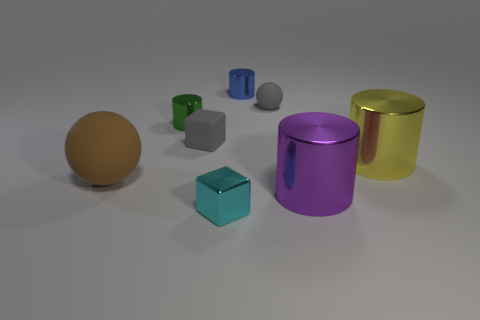Add 2 large yellow cylinders. How many objects exist? 10 Subtract all spheres. How many objects are left? 6 Add 4 small gray objects. How many small gray objects are left? 6 Add 2 blue cylinders. How many blue cylinders exist? 3 Subtract 0 red blocks. How many objects are left? 8 Subtract all large red rubber balls. Subtract all small objects. How many objects are left? 3 